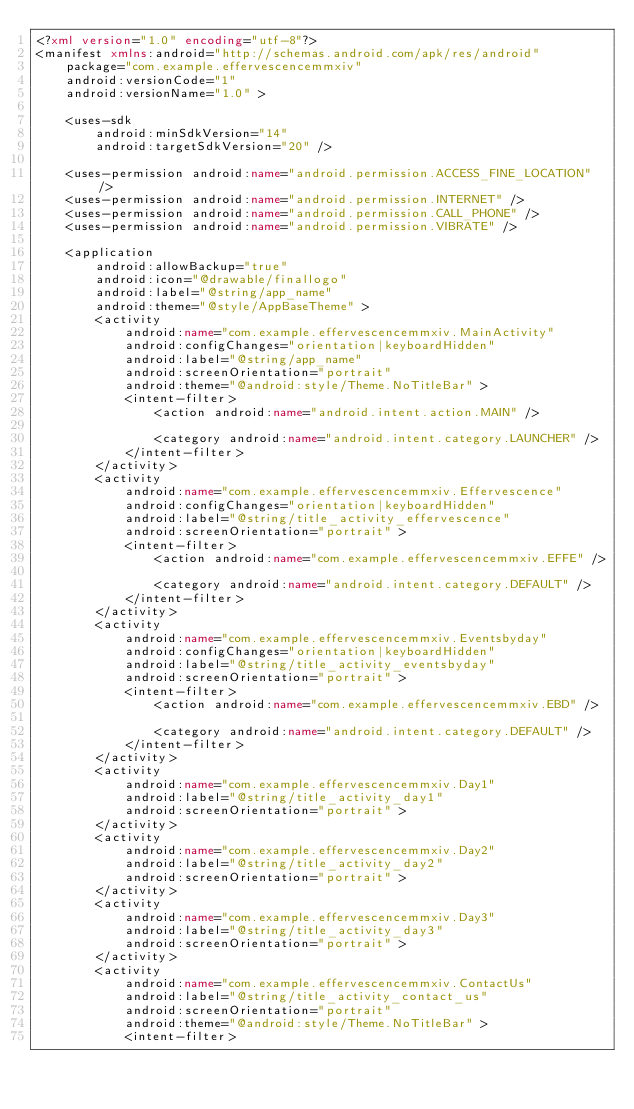Convert code to text. <code><loc_0><loc_0><loc_500><loc_500><_XML_><?xml version="1.0" encoding="utf-8"?>
<manifest xmlns:android="http://schemas.android.com/apk/res/android"
    package="com.example.effervescencemmxiv"
    android:versionCode="1"
    android:versionName="1.0" >

    <uses-sdk
        android:minSdkVersion="14"
        android:targetSdkVersion="20" />

    <uses-permission android:name="android.permission.ACCESS_FINE_LOCATION" />
    <uses-permission android:name="android.permission.INTERNET" />
    <uses-permission android:name="android.permission.CALL_PHONE" />
    <uses-permission android:name="android.permission.VIBRATE" />

    <application
        android:allowBackup="true"
        android:icon="@drawable/finallogo"
        android:label="@string/app_name"
        android:theme="@style/AppBaseTheme" >
        <activity
            android:name="com.example.effervescencemmxiv.MainActivity"
            android:configChanges="orientation|keyboardHidden"
            android:label="@string/app_name"
            android:screenOrientation="portrait"
            android:theme="@android:style/Theme.NoTitleBar" >
            <intent-filter>
                <action android:name="android.intent.action.MAIN" />

                <category android:name="android.intent.category.LAUNCHER" />
            </intent-filter>
        </activity>
        <activity
            android:name="com.example.effervescencemmxiv.Effervescence"
            android:configChanges="orientation|keyboardHidden"
            android:label="@string/title_activity_effervescence"
            android:screenOrientation="portrait" >
            <intent-filter>
                <action android:name="com.example.effervescencemmxiv.EFFE" />

                <category android:name="android.intent.category.DEFAULT" />
            </intent-filter>
        </activity>
        <activity
            android:name="com.example.effervescencemmxiv.Eventsbyday"
            android:configChanges="orientation|keyboardHidden"
            android:label="@string/title_activity_eventsbyday"
            android:screenOrientation="portrait" >
            <intent-filter>
                <action android:name="com.example.effervescencemmxiv.EBD" />

                <category android:name="android.intent.category.DEFAULT" />
            </intent-filter>
        </activity>
        <activity
            android:name="com.example.effervescencemmxiv.Day1"
            android:label="@string/title_activity_day1"
            android:screenOrientation="portrait" >
        </activity>
        <activity
            android:name="com.example.effervescencemmxiv.Day2"
            android:label="@string/title_activity_day2"
            android:screenOrientation="portrait" >
        </activity>
        <activity
            android:name="com.example.effervescencemmxiv.Day3"
            android:label="@string/title_activity_day3"
            android:screenOrientation="portrait" >
        </activity>
        <activity
            android:name="com.example.effervescencemmxiv.ContactUs"
            android:label="@string/title_activity_contact_us"
            android:screenOrientation="portrait"
            android:theme="@android:style/Theme.NoTitleBar" >
            <intent-filter></code> 